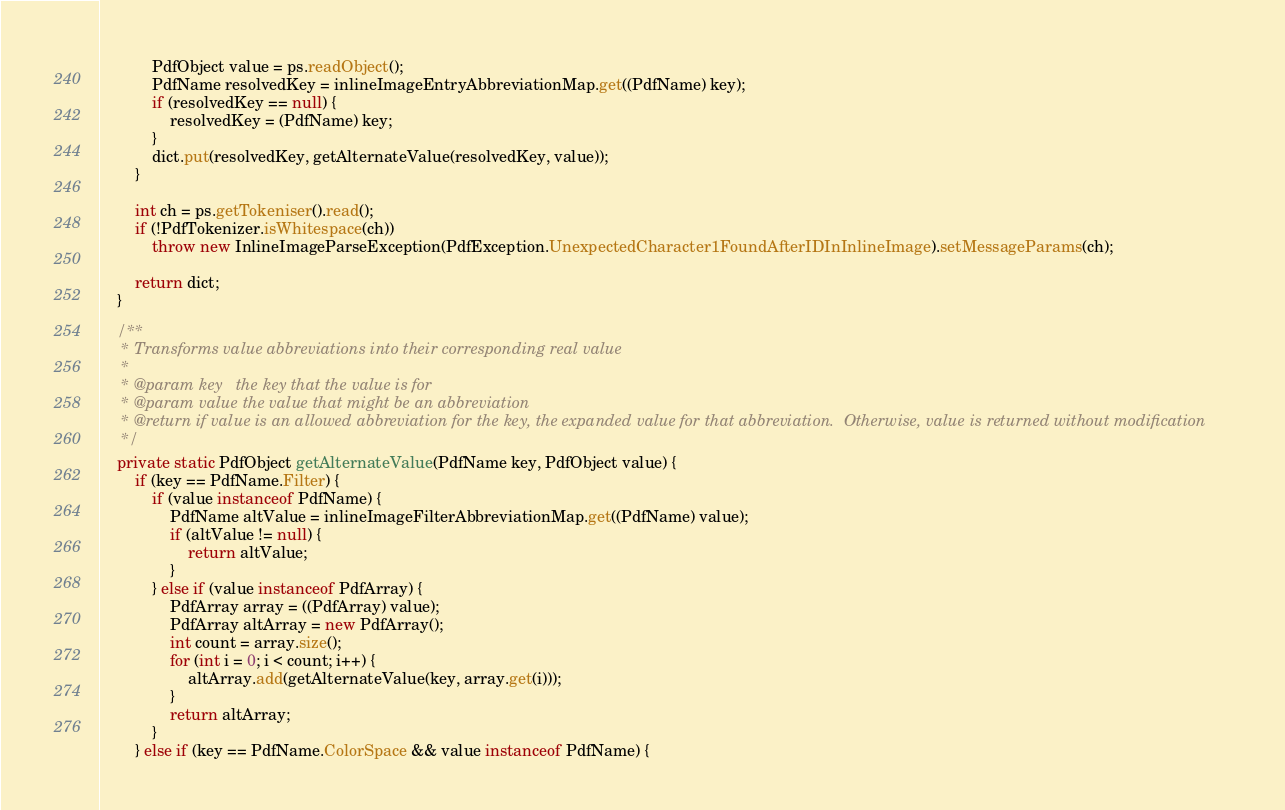Convert code to text. <code><loc_0><loc_0><loc_500><loc_500><_Java_>            PdfObject value = ps.readObject();
            PdfName resolvedKey = inlineImageEntryAbbreviationMap.get((PdfName) key);
            if (resolvedKey == null) {
                resolvedKey = (PdfName) key;
            }
            dict.put(resolvedKey, getAlternateValue(resolvedKey, value));
        }

        int ch = ps.getTokeniser().read();
        if (!PdfTokenizer.isWhitespace(ch))
            throw new InlineImageParseException(PdfException.UnexpectedCharacter1FoundAfterIDInInlineImage).setMessageParams(ch);

        return dict;
    }

    /**
     * Transforms value abbreviations into their corresponding real value
     *
     * @param key   the key that the value is for
     * @param value the value that might be an abbreviation
     * @return if value is an allowed abbreviation for the key, the expanded value for that abbreviation.  Otherwise, value is returned without modification
     */
    private static PdfObject getAlternateValue(PdfName key, PdfObject value) {
        if (key == PdfName.Filter) {
            if (value instanceof PdfName) {
                PdfName altValue = inlineImageFilterAbbreviationMap.get((PdfName) value);
                if (altValue != null) {
                    return altValue;
                }
            } else if (value instanceof PdfArray) {
                PdfArray array = ((PdfArray) value);
                PdfArray altArray = new PdfArray();
                int count = array.size();
                for (int i = 0; i < count; i++) {
                    altArray.add(getAlternateValue(key, array.get(i)));
                }
                return altArray;
            }
        } else if (key == PdfName.ColorSpace && value instanceof PdfName) {</code> 